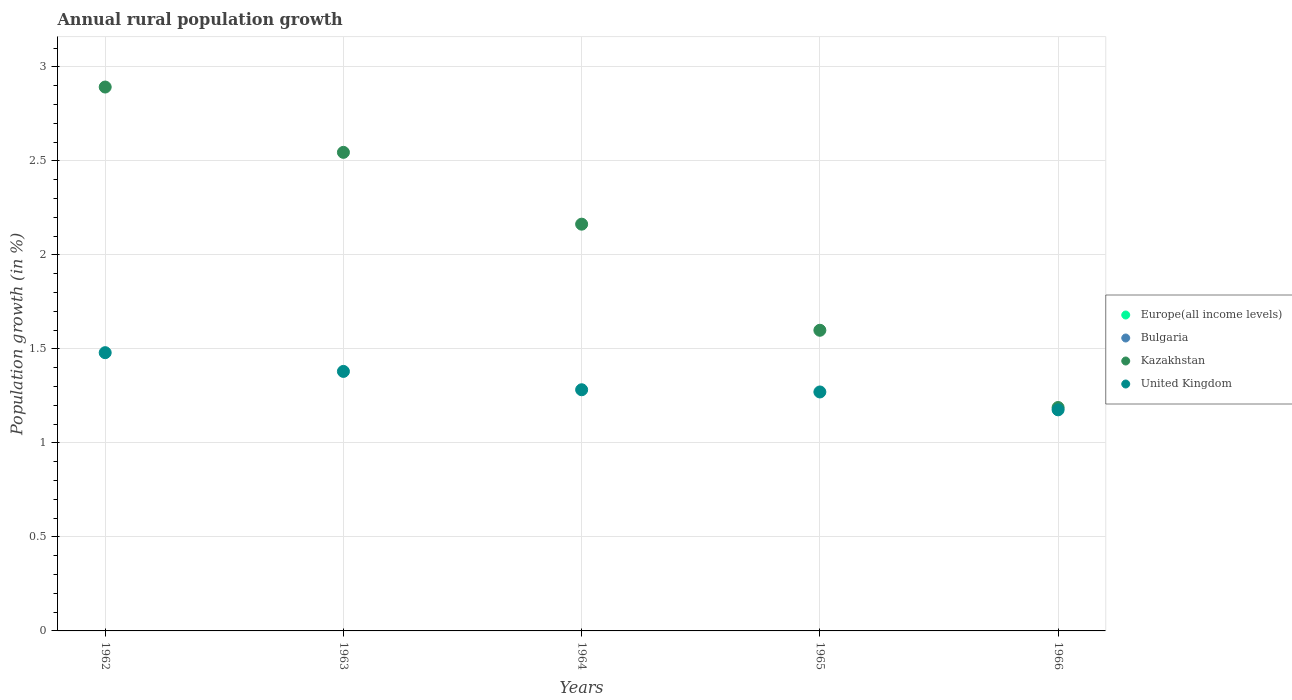Is the number of dotlines equal to the number of legend labels?
Offer a very short reply. No. What is the percentage of rural population growth in Kazakhstan in 1966?
Offer a very short reply. 1.19. Across all years, what is the maximum percentage of rural population growth in United Kingdom?
Keep it short and to the point. 1.48. Across all years, what is the minimum percentage of rural population growth in Europe(all income levels)?
Keep it short and to the point. 0. In which year was the percentage of rural population growth in United Kingdom maximum?
Your response must be concise. 1962. What is the difference between the percentage of rural population growth in United Kingdom in 1963 and that in 1964?
Your response must be concise. 0.1. What is the difference between the percentage of rural population growth in Bulgaria in 1964 and the percentage of rural population growth in United Kingdom in 1965?
Offer a very short reply. -1.27. What is the average percentage of rural population growth in United Kingdom per year?
Keep it short and to the point. 1.32. In the year 1963, what is the difference between the percentage of rural population growth in Kazakhstan and percentage of rural population growth in United Kingdom?
Make the answer very short. 1.17. What is the ratio of the percentage of rural population growth in Kazakhstan in 1962 to that in 1964?
Keep it short and to the point. 1.34. Is the difference between the percentage of rural population growth in Kazakhstan in 1963 and 1964 greater than the difference between the percentage of rural population growth in United Kingdom in 1963 and 1964?
Give a very brief answer. Yes. What is the difference between the highest and the lowest percentage of rural population growth in Kazakhstan?
Provide a short and direct response. 1.7. In how many years, is the percentage of rural population growth in Bulgaria greater than the average percentage of rural population growth in Bulgaria taken over all years?
Offer a terse response. 0. Is the sum of the percentage of rural population growth in Kazakhstan in 1962 and 1965 greater than the maximum percentage of rural population growth in United Kingdom across all years?
Give a very brief answer. Yes. Is it the case that in every year, the sum of the percentage of rural population growth in United Kingdom and percentage of rural population growth in Europe(all income levels)  is greater than the percentage of rural population growth in Kazakhstan?
Your answer should be very brief. No. Is the percentage of rural population growth in United Kingdom strictly less than the percentage of rural population growth in Kazakhstan over the years?
Your response must be concise. Yes. How many years are there in the graph?
Provide a succinct answer. 5. Are the values on the major ticks of Y-axis written in scientific E-notation?
Provide a succinct answer. No. Does the graph contain any zero values?
Your answer should be compact. Yes. Does the graph contain grids?
Give a very brief answer. Yes. How many legend labels are there?
Make the answer very short. 4. How are the legend labels stacked?
Your answer should be very brief. Vertical. What is the title of the graph?
Your answer should be very brief. Annual rural population growth. Does "Paraguay" appear as one of the legend labels in the graph?
Make the answer very short. No. What is the label or title of the X-axis?
Keep it short and to the point. Years. What is the label or title of the Y-axis?
Keep it short and to the point. Population growth (in %). What is the Population growth (in %) in Europe(all income levels) in 1962?
Provide a succinct answer. 0. What is the Population growth (in %) of Kazakhstan in 1962?
Provide a short and direct response. 2.89. What is the Population growth (in %) in United Kingdom in 1962?
Your answer should be very brief. 1.48. What is the Population growth (in %) in Bulgaria in 1963?
Make the answer very short. 0. What is the Population growth (in %) in Kazakhstan in 1963?
Make the answer very short. 2.55. What is the Population growth (in %) in United Kingdom in 1963?
Provide a succinct answer. 1.38. What is the Population growth (in %) in Bulgaria in 1964?
Give a very brief answer. 0. What is the Population growth (in %) in Kazakhstan in 1964?
Offer a very short reply. 2.16. What is the Population growth (in %) in United Kingdom in 1964?
Your answer should be very brief. 1.28. What is the Population growth (in %) of Bulgaria in 1965?
Provide a short and direct response. 0. What is the Population growth (in %) of Kazakhstan in 1965?
Your response must be concise. 1.6. What is the Population growth (in %) of United Kingdom in 1965?
Give a very brief answer. 1.27. What is the Population growth (in %) in Europe(all income levels) in 1966?
Your answer should be compact. 0. What is the Population growth (in %) in Kazakhstan in 1966?
Give a very brief answer. 1.19. What is the Population growth (in %) in United Kingdom in 1966?
Give a very brief answer. 1.18. Across all years, what is the maximum Population growth (in %) in Kazakhstan?
Make the answer very short. 2.89. Across all years, what is the maximum Population growth (in %) of United Kingdom?
Offer a very short reply. 1.48. Across all years, what is the minimum Population growth (in %) in Kazakhstan?
Give a very brief answer. 1.19. Across all years, what is the minimum Population growth (in %) of United Kingdom?
Your answer should be very brief. 1.18. What is the total Population growth (in %) of Bulgaria in the graph?
Keep it short and to the point. 0. What is the total Population growth (in %) of Kazakhstan in the graph?
Provide a short and direct response. 10.39. What is the total Population growth (in %) of United Kingdom in the graph?
Your answer should be very brief. 6.59. What is the difference between the Population growth (in %) of Kazakhstan in 1962 and that in 1963?
Your answer should be compact. 0.35. What is the difference between the Population growth (in %) in United Kingdom in 1962 and that in 1963?
Your answer should be very brief. 0.1. What is the difference between the Population growth (in %) in Kazakhstan in 1962 and that in 1964?
Your answer should be compact. 0.73. What is the difference between the Population growth (in %) of United Kingdom in 1962 and that in 1964?
Provide a short and direct response. 0.2. What is the difference between the Population growth (in %) of Kazakhstan in 1962 and that in 1965?
Offer a very short reply. 1.29. What is the difference between the Population growth (in %) in United Kingdom in 1962 and that in 1965?
Give a very brief answer. 0.21. What is the difference between the Population growth (in %) in Kazakhstan in 1962 and that in 1966?
Give a very brief answer. 1.7. What is the difference between the Population growth (in %) of United Kingdom in 1962 and that in 1966?
Provide a short and direct response. 0.3. What is the difference between the Population growth (in %) in Kazakhstan in 1963 and that in 1964?
Provide a succinct answer. 0.38. What is the difference between the Population growth (in %) of United Kingdom in 1963 and that in 1964?
Offer a very short reply. 0.1. What is the difference between the Population growth (in %) of Kazakhstan in 1963 and that in 1965?
Provide a succinct answer. 0.95. What is the difference between the Population growth (in %) of United Kingdom in 1963 and that in 1965?
Offer a terse response. 0.11. What is the difference between the Population growth (in %) in Kazakhstan in 1963 and that in 1966?
Provide a short and direct response. 1.36. What is the difference between the Population growth (in %) in United Kingdom in 1963 and that in 1966?
Provide a succinct answer. 0.2. What is the difference between the Population growth (in %) of Kazakhstan in 1964 and that in 1965?
Give a very brief answer. 0.56. What is the difference between the Population growth (in %) of United Kingdom in 1964 and that in 1965?
Make the answer very short. 0.01. What is the difference between the Population growth (in %) in Kazakhstan in 1964 and that in 1966?
Offer a very short reply. 0.98. What is the difference between the Population growth (in %) of United Kingdom in 1964 and that in 1966?
Offer a very short reply. 0.11. What is the difference between the Population growth (in %) in Kazakhstan in 1965 and that in 1966?
Keep it short and to the point. 0.41. What is the difference between the Population growth (in %) of United Kingdom in 1965 and that in 1966?
Provide a short and direct response. 0.1. What is the difference between the Population growth (in %) in Kazakhstan in 1962 and the Population growth (in %) in United Kingdom in 1963?
Provide a succinct answer. 1.51. What is the difference between the Population growth (in %) in Kazakhstan in 1962 and the Population growth (in %) in United Kingdom in 1964?
Keep it short and to the point. 1.61. What is the difference between the Population growth (in %) in Kazakhstan in 1962 and the Population growth (in %) in United Kingdom in 1965?
Provide a short and direct response. 1.62. What is the difference between the Population growth (in %) in Kazakhstan in 1962 and the Population growth (in %) in United Kingdom in 1966?
Your answer should be very brief. 1.72. What is the difference between the Population growth (in %) of Kazakhstan in 1963 and the Population growth (in %) of United Kingdom in 1964?
Make the answer very short. 1.26. What is the difference between the Population growth (in %) in Kazakhstan in 1963 and the Population growth (in %) in United Kingdom in 1965?
Your response must be concise. 1.27. What is the difference between the Population growth (in %) in Kazakhstan in 1963 and the Population growth (in %) in United Kingdom in 1966?
Provide a short and direct response. 1.37. What is the difference between the Population growth (in %) in Kazakhstan in 1964 and the Population growth (in %) in United Kingdom in 1965?
Your response must be concise. 0.89. What is the difference between the Population growth (in %) in Kazakhstan in 1964 and the Population growth (in %) in United Kingdom in 1966?
Provide a short and direct response. 0.99. What is the difference between the Population growth (in %) of Kazakhstan in 1965 and the Population growth (in %) of United Kingdom in 1966?
Your answer should be compact. 0.42. What is the average Population growth (in %) in Europe(all income levels) per year?
Provide a short and direct response. 0. What is the average Population growth (in %) of Kazakhstan per year?
Your answer should be compact. 2.08. What is the average Population growth (in %) in United Kingdom per year?
Your response must be concise. 1.32. In the year 1962, what is the difference between the Population growth (in %) of Kazakhstan and Population growth (in %) of United Kingdom?
Provide a short and direct response. 1.41. In the year 1963, what is the difference between the Population growth (in %) of Kazakhstan and Population growth (in %) of United Kingdom?
Ensure brevity in your answer.  1.17. In the year 1964, what is the difference between the Population growth (in %) in Kazakhstan and Population growth (in %) in United Kingdom?
Give a very brief answer. 0.88. In the year 1965, what is the difference between the Population growth (in %) of Kazakhstan and Population growth (in %) of United Kingdom?
Provide a succinct answer. 0.33. In the year 1966, what is the difference between the Population growth (in %) in Kazakhstan and Population growth (in %) in United Kingdom?
Provide a short and direct response. 0.01. What is the ratio of the Population growth (in %) in Kazakhstan in 1962 to that in 1963?
Your response must be concise. 1.14. What is the ratio of the Population growth (in %) of United Kingdom in 1962 to that in 1963?
Your answer should be very brief. 1.07. What is the ratio of the Population growth (in %) in Kazakhstan in 1962 to that in 1964?
Provide a short and direct response. 1.34. What is the ratio of the Population growth (in %) in United Kingdom in 1962 to that in 1964?
Provide a short and direct response. 1.15. What is the ratio of the Population growth (in %) of Kazakhstan in 1962 to that in 1965?
Your response must be concise. 1.81. What is the ratio of the Population growth (in %) of United Kingdom in 1962 to that in 1965?
Offer a terse response. 1.16. What is the ratio of the Population growth (in %) of Kazakhstan in 1962 to that in 1966?
Offer a very short reply. 2.43. What is the ratio of the Population growth (in %) of United Kingdom in 1962 to that in 1966?
Provide a succinct answer. 1.26. What is the ratio of the Population growth (in %) of Kazakhstan in 1963 to that in 1964?
Offer a very short reply. 1.18. What is the ratio of the Population growth (in %) in United Kingdom in 1963 to that in 1964?
Your answer should be very brief. 1.08. What is the ratio of the Population growth (in %) in Kazakhstan in 1963 to that in 1965?
Provide a succinct answer. 1.59. What is the ratio of the Population growth (in %) of United Kingdom in 1963 to that in 1965?
Provide a short and direct response. 1.09. What is the ratio of the Population growth (in %) of Kazakhstan in 1963 to that in 1966?
Make the answer very short. 2.14. What is the ratio of the Population growth (in %) in United Kingdom in 1963 to that in 1966?
Make the answer very short. 1.17. What is the ratio of the Population growth (in %) of Kazakhstan in 1964 to that in 1965?
Your response must be concise. 1.35. What is the ratio of the Population growth (in %) of United Kingdom in 1964 to that in 1965?
Make the answer very short. 1.01. What is the ratio of the Population growth (in %) in Kazakhstan in 1964 to that in 1966?
Your answer should be compact. 1.82. What is the ratio of the Population growth (in %) of United Kingdom in 1964 to that in 1966?
Keep it short and to the point. 1.09. What is the ratio of the Population growth (in %) of Kazakhstan in 1965 to that in 1966?
Your answer should be very brief. 1.35. What is the ratio of the Population growth (in %) of United Kingdom in 1965 to that in 1966?
Your response must be concise. 1.08. What is the difference between the highest and the second highest Population growth (in %) in Kazakhstan?
Ensure brevity in your answer.  0.35. What is the difference between the highest and the second highest Population growth (in %) of United Kingdom?
Your answer should be compact. 0.1. What is the difference between the highest and the lowest Population growth (in %) of Kazakhstan?
Make the answer very short. 1.7. What is the difference between the highest and the lowest Population growth (in %) of United Kingdom?
Give a very brief answer. 0.3. 